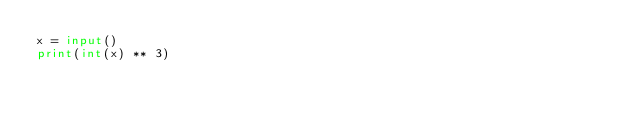Convert code to text. <code><loc_0><loc_0><loc_500><loc_500><_Python_>x = input()
print(int(x) ** 3)
</code> 